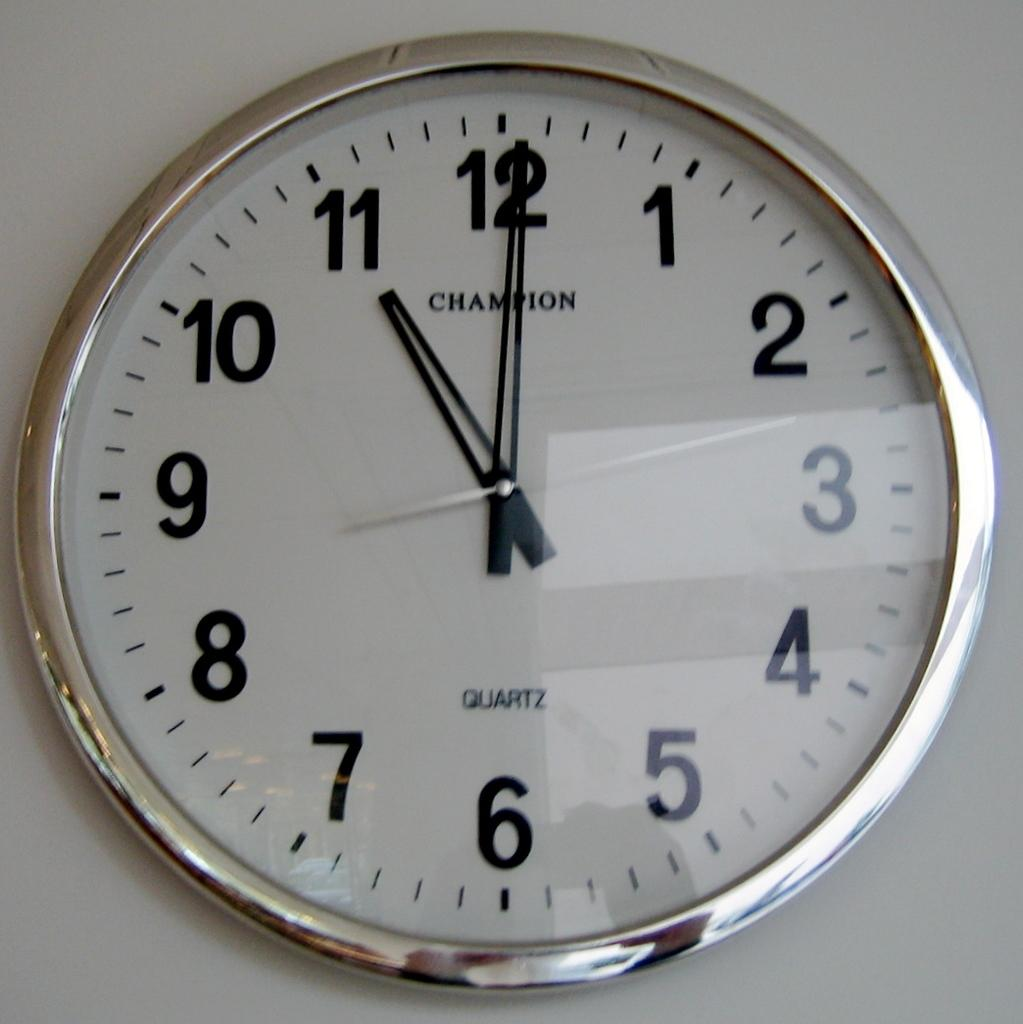<image>
Write a terse but informative summary of the picture. Wall clock showing 11 o'clock, brand name Champion. 